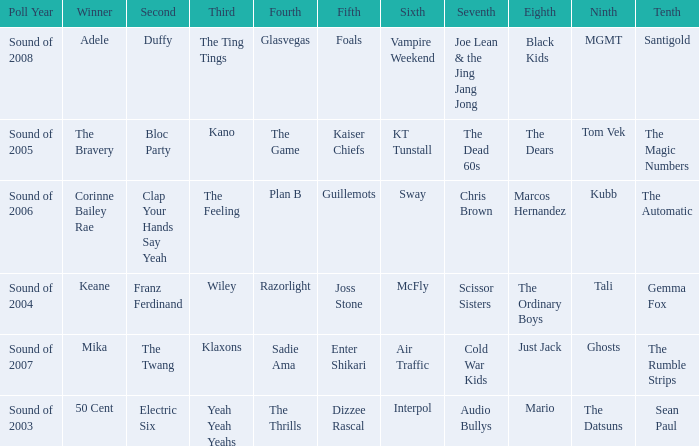How many times was Plan B 4th place? 1.0. 